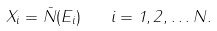Convert formula to latex. <formula><loc_0><loc_0><loc_500><loc_500>X _ { i } = \bar { N } ( E _ { i } ) \quad i = 1 , 2 , \dots N .</formula> 